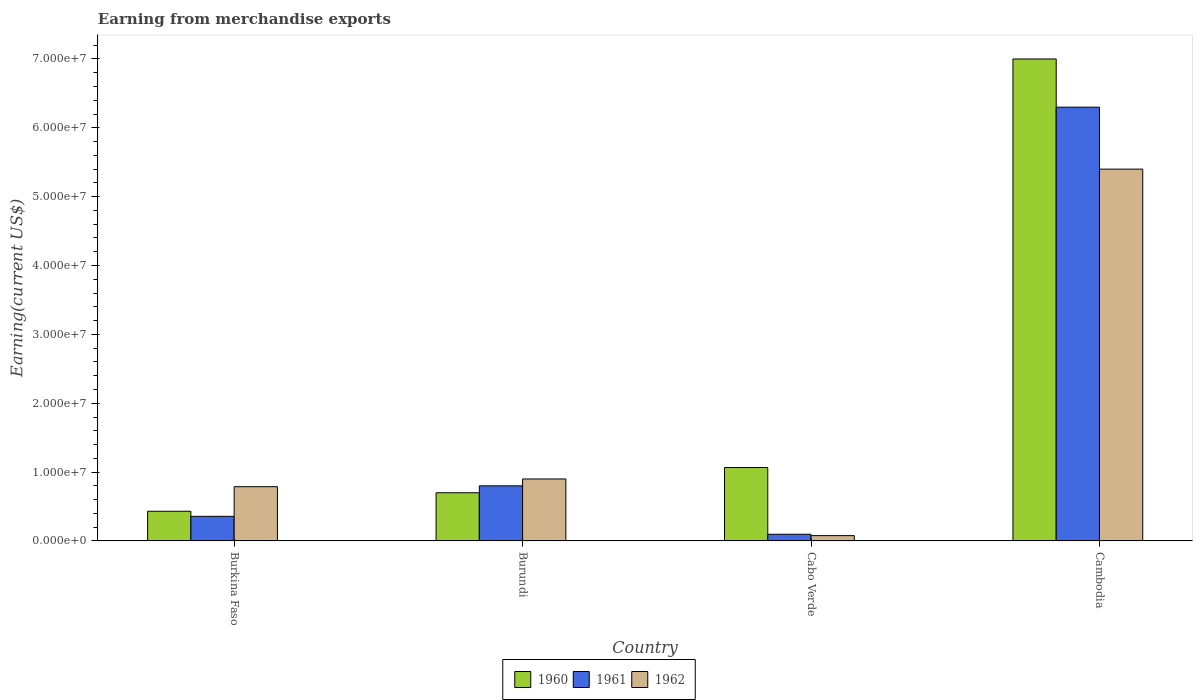How many different coloured bars are there?
Give a very brief answer. 3. Are the number of bars on each tick of the X-axis equal?
Give a very brief answer. Yes. How many bars are there on the 4th tick from the right?
Make the answer very short. 3. What is the label of the 4th group of bars from the left?
Make the answer very short. Cambodia. What is the amount earned from merchandise exports in 1961 in Cabo Verde?
Provide a short and direct response. 9.67e+05. Across all countries, what is the maximum amount earned from merchandise exports in 1960?
Your answer should be compact. 7.00e+07. Across all countries, what is the minimum amount earned from merchandise exports in 1962?
Your response must be concise. 7.72e+05. In which country was the amount earned from merchandise exports in 1962 maximum?
Keep it short and to the point. Cambodia. In which country was the amount earned from merchandise exports in 1962 minimum?
Provide a succinct answer. Cabo Verde. What is the total amount earned from merchandise exports in 1960 in the graph?
Offer a very short reply. 9.20e+07. What is the difference between the amount earned from merchandise exports in 1961 in Burkina Faso and that in Cabo Verde?
Ensure brevity in your answer.  2.61e+06. What is the difference between the amount earned from merchandise exports in 1961 in Burundi and the amount earned from merchandise exports in 1962 in Cambodia?
Your response must be concise. -4.60e+07. What is the average amount earned from merchandise exports in 1961 per country?
Make the answer very short. 1.89e+07. What is the difference between the amount earned from merchandise exports of/in 1961 and amount earned from merchandise exports of/in 1962 in Cabo Verde?
Ensure brevity in your answer.  1.95e+05. In how many countries, is the amount earned from merchandise exports in 1960 greater than 18000000 US$?
Keep it short and to the point. 1. What is the ratio of the amount earned from merchandise exports in 1961 in Burundi to that in Cabo Verde?
Provide a short and direct response. 8.27. Is the difference between the amount earned from merchandise exports in 1961 in Burkina Faso and Burundi greater than the difference between the amount earned from merchandise exports in 1962 in Burkina Faso and Burundi?
Offer a terse response. No. What is the difference between the highest and the second highest amount earned from merchandise exports in 1961?
Make the answer very short. 5.50e+07. What is the difference between the highest and the lowest amount earned from merchandise exports in 1961?
Your answer should be compact. 6.20e+07. What does the 2nd bar from the right in Cabo Verde represents?
Your response must be concise. 1961. How many bars are there?
Your response must be concise. 12. How many countries are there in the graph?
Give a very brief answer. 4. How are the legend labels stacked?
Give a very brief answer. Horizontal. What is the title of the graph?
Provide a succinct answer. Earning from merchandise exports. What is the label or title of the X-axis?
Your response must be concise. Country. What is the label or title of the Y-axis?
Offer a terse response. Earning(current US$). What is the Earning(current US$) of 1960 in Burkina Faso?
Offer a terse response. 4.31e+06. What is the Earning(current US$) in 1961 in Burkina Faso?
Provide a succinct answer. 3.57e+06. What is the Earning(current US$) in 1962 in Burkina Faso?
Provide a succinct answer. 7.88e+06. What is the Earning(current US$) of 1961 in Burundi?
Give a very brief answer. 8.00e+06. What is the Earning(current US$) of 1962 in Burundi?
Your answer should be very brief. 9.00e+06. What is the Earning(current US$) of 1960 in Cabo Verde?
Make the answer very short. 1.07e+07. What is the Earning(current US$) in 1961 in Cabo Verde?
Keep it short and to the point. 9.67e+05. What is the Earning(current US$) in 1962 in Cabo Verde?
Provide a succinct answer. 7.72e+05. What is the Earning(current US$) in 1960 in Cambodia?
Make the answer very short. 7.00e+07. What is the Earning(current US$) of 1961 in Cambodia?
Give a very brief answer. 6.30e+07. What is the Earning(current US$) of 1962 in Cambodia?
Keep it short and to the point. 5.40e+07. Across all countries, what is the maximum Earning(current US$) in 1960?
Make the answer very short. 7.00e+07. Across all countries, what is the maximum Earning(current US$) in 1961?
Your response must be concise. 6.30e+07. Across all countries, what is the maximum Earning(current US$) in 1962?
Provide a short and direct response. 5.40e+07. Across all countries, what is the minimum Earning(current US$) in 1960?
Your response must be concise. 4.31e+06. Across all countries, what is the minimum Earning(current US$) in 1961?
Offer a very short reply. 9.67e+05. Across all countries, what is the minimum Earning(current US$) of 1962?
Your answer should be compact. 7.72e+05. What is the total Earning(current US$) in 1960 in the graph?
Keep it short and to the point. 9.20e+07. What is the total Earning(current US$) of 1961 in the graph?
Offer a terse response. 7.55e+07. What is the total Earning(current US$) of 1962 in the graph?
Your response must be concise. 7.17e+07. What is the difference between the Earning(current US$) in 1960 in Burkina Faso and that in Burundi?
Offer a terse response. -2.69e+06. What is the difference between the Earning(current US$) in 1961 in Burkina Faso and that in Burundi?
Offer a very short reply. -4.43e+06. What is the difference between the Earning(current US$) of 1962 in Burkina Faso and that in Burundi?
Keep it short and to the point. -1.12e+06. What is the difference between the Earning(current US$) in 1960 in Burkina Faso and that in Cabo Verde?
Make the answer very short. -6.35e+06. What is the difference between the Earning(current US$) of 1961 in Burkina Faso and that in Cabo Verde?
Your response must be concise. 2.61e+06. What is the difference between the Earning(current US$) in 1962 in Burkina Faso and that in Cabo Verde?
Ensure brevity in your answer.  7.11e+06. What is the difference between the Earning(current US$) in 1960 in Burkina Faso and that in Cambodia?
Ensure brevity in your answer.  -6.57e+07. What is the difference between the Earning(current US$) in 1961 in Burkina Faso and that in Cambodia?
Offer a very short reply. -5.94e+07. What is the difference between the Earning(current US$) of 1962 in Burkina Faso and that in Cambodia?
Make the answer very short. -4.61e+07. What is the difference between the Earning(current US$) in 1960 in Burundi and that in Cabo Verde?
Your answer should be compact. -3.66e+06. What is the difference between the Earning(current US$) in 1961 in Burundi and that in Cabo Verde?
Provide a short and direct response. 7.03e+06. What is the difference between the Earning(current US$) in 1962 in Burundi and that in Cabo Verde?
Offer a terse response. 8.23e+06. What is the difference between the Earning(current US$) in 1960 in Burundi and that in Cambodia?
Make the answer very short. -6.30e+07. What is the difference between the Earning(current US$) of 1961 in Burundi and that in Cambodia?
Offer a terse response. -5.50e+07. What is the difference between the Earning(current US$) of 1962 in Burundi and that in Cambodia?
Provide a short and direct response. -4.50e+07. What is the difference between the Earning(current US$) in 1960 in Cabo Verde and that in Cambodia?
Your response must be concise. -5.93e+07. What is the difference between the Earning(current US$) in 1961 in Cabo Verde and that in Cambodia?
Ensure brevity in your answer.  -6.20e+07. What is the difference between the Earning(current US$) of 1962 in Cabo Verde and that in Cambodia?
Ensure brevity in your answer.  -5.32e+07. What is the difference between the Earning(current US$) in 1960 in Burkina Faso and the Earning(current US$) in 1961 in Burundi?
Offer a very short reply. -3.69e+06. What is the difference between the Earning(current US$) in 1960 in Burkina Faso and the Earning(current US$) in 1962 in Burundi?
Your answer should be very brief. -4.69e+06. What is the difference between the Earning(current US$) in 1961 in Burkina Faso and the Earning(current US$) in 1962 in Burundi?
Give a very brief answer. -5.43e+06. What is the difference between the Earning(current US$) in 1960 in Burkina Faso and the Earning(current US$) in 1961 in Cabo Verde?
Provide a short and direct response. 3.34e+06. What is the difference between the Earning(current US$) of 1960 in Burkina Faso and the Earning(current US$) of 1962 in Cabo Verde?
Offer a terse response. 3.54e+06. What is the difference between the Earning(current US$) in 1961 in Burkina Faso and the Earning(current US$) in 1962 in Cabo Verde?
Your response must be concise. 2.80e+06. What is the difference between the Earning(current US$) in 1960 in Burkina Faso and the Earning(current US$) in 1961 in Cambodia?
Your response must be concise. -5.87e+07. What is the difference between the Earning(current US$) in 1960 in Burkina Faso and the Earning(current US$) in 1962 in Cambodia?
Provide a short and direct response. -4.97e+07. What is the difference between the Earning(current US$) of 1961 in Burkina Faso and the Earning(current US$) of 1962 in Cambodia?
Keep it short and to the point. -5.04e+07. What is the difference between the Earning(current US$) of 1960 in Burundi and the Earning(current US$) of 1961 in Cabo Verde?
Your answer should be very brief. 6.03e+06. What is the difference between the Earning(current US$) in 1960 in Burundi and the Earning(current US$) in 1962 in Cabo Verde?
Provide a succinct answer. 6.23e+06. What is the difference between the Earning(current US$) of 1961 in Burundi and the Earning(current US$) of 1962 in Cabo Verde?
Ensure brevity in your answer.  7.23e+06. What is the difference between the Earning(current US$) in 1960 in Burundi and the Earning(current US$) in 1961 in Cambodia?
Offer a terse response. -5.60e+07. What is the difference between the Earning(current US$) in 1960 in Burundi and the Earning(current US$) in 1962 in Cambodia?
Keep it short and to the point. -4.70e+07. What is the difference between the Earning(current US$) of 1961 in Burundi and the Earning(current US$) of 1962 in Cambodia?
Ensure brevity in your answer.  -4.60e+07. What is the difference between the Earning(current US$) in 1960 in Cabo Verde and the Earning(current US$) in 1961 in Cambodia?
Keep it short and to the point. -5.23e+07. What is the difference between the Earning(current US$) of 1960 in Cabo Verde and the Earning(current US$) of 1962 in Cambodia?
Provide a short and direct response. -4.33e+07. What is the difference between the Earning(current US$) of 1961 in Cabo Verde and the Earning(current US$) of 1962 in Cambodia?
Your response must be concise. -5.30e+07. What is the average Earning(current US$) of 1960 per country?
Offer a very short reply. 2.30e+07. What is the average Earning(current US$) of 1961 per country?
Give a very brief answer. 1.89e+07. What is the average Earning(current US$) in 1962 per country?
Provide a short and direct response. 1.79e+07. What is the difference between the Earning(current US$) of 1960 and Earning(current US$) of 1961 in Burkina Faso?
Make the answer very short. 7.37e+05. What is the difference between the Earning(current US$) in 1960 and Earning(current US$) in 1962 in Burkina Faso?
Your response must be concise. -3.57e+06. What is the difference between the Earning(current US$) of 1961 and Earning(current US$) of 1962 in Burkina Faso?
Give a very brief answer. -4.31e+06. What is the difference between the Earning(current US$) of 1960 and Earning(current US$) of 1962 in Burundi?
Provide a short and direct response. -2.00e+06. What is the difference between the Earning(current US$) of 1961 and Earning(current US$) of 1962 in Burundi?
Your response must be concise. -1.00e+06. What is the difference between the Earning(current US$) in 1960 and Earning(current US$) in 1961 in Cabo Verde?
Give a very brief answer. 9.69e+06. What is the difference between the Earning(current US$) of 1960 and Earning(current US$) of 1962 in Cabo Verde?
Your response must be concise. 9.89e+06. What is the difference between the Earning(current US$) in 1961 and Earning(current US$) in 1962 in Cabo Verde?
Your answer should be very brief. 1.95e+05. What is the difference between the Earning(current US$) of 1960 and Earning(current US$) of 1961 in Cambodia?
Offer a very short reply. 7.00e+06. What is the difference between the Earning(current US$) in 1960 and Earning(current US$) in 1962 in Cambodia?
Ensure brevity in your answer.  1.60e+07. What is the difference between the Earning(current US$) of 1961 and Earning(current US$) of 1962 in Cambodia?
Offer a terse response. 9.00e+06. What is the ratio of the Earning(current US$) of 1960 in Burkina Faso to that in Burundi?
Ensure brevity in your answer.  0.62. What is the ratio of the Earning(current US$) in 1961 in Burkina Faso to that in Burundi?
Provide a short and direct response. 0.45. What is the ratio of the Earning(current US$) in 1962 in Burkina Faso to that in Burundi?
Your answer should be very brief. 0.88. What is the ratio of the Earning(current US$) of 1960 in Burkina Faso to that in Cabo Verde?
Keep it short and to the point. 0.4. What is the ratio of the Earning(current US$) of 1961 in Burkina Faso to that in Cabo Verde?
Give a very brief answer. 3.69. What is the ratio of the Earning(current US$) of 1962 in Burkina Faso to that in Cabo Verde?
Offer a terse response. 10.21. What is the ratio of the Earning(current US$) in 1960 in Burkina Faso to that in Cambodia?
Provide a short and direct response. 0.06. What is the ratio of the Earning(current US$) in 1961 in Burkina Faso to that in Cambodia?
Make the answer very short. 0.06. What is the ratio of the Earning(current US$) of 1962 in Burkina Faso to that in Cambodia?
Give a very brief answer. 0.15. What is the ratio of the Earning(current US$) in 1960 in Burundi to that in Cabo Verde?
Ensure brevity in your answer.  0.66. What is the ratio of the Earning(current US$) in 1961 in Burundi to that in Cabo Verde?
Your answer should be compact. 8.27. What is the ratio of the Earning(current US$) of 1962 in Burundi to that in Cabo Verde?
Ensure brevity in your answer.  11.66. What is the ratio of the Earning(current US$) in 1961 in Burundi to that in Cambodia?
Make the answer very short. 0.13. What is the ratio of the Earning(current US$) in 1962 in Burundi to that in Cambodia?
Provide a short and direct response. 0.17. What is the ratio of the Earning(current US$) in 1960 in Cabo Verde to that in Cambodia?
Your response must be concise. 0.15. What is the ratio of the Earning(current US$) in 1961 in Cabo Verde to that in Cambodia?
Make the answer very short. 0.02. What is the ratio of the Earning(current US$) of 1962 in Cabo Verde to that in Cambodia?
Your answer should be compact. 0.01. What is the difference between the highest and the second highest Earning(current US$) of 1960?
Your answer should be very brief. 5.93e+07. What is the difference between the highest and the second highest Earning(current US$) in 1961?
Offer a very short reply. 5.50e+07. What is the difference between the highest and the second highest Earning(current US$) of 1962?
Provide a succinct answer. 4.50e+07. What is the difference between the highest and the lowest Earning(current US$) in 1960?
Offer a very short reply. 6.57e+07. What is the difference between the highest and the lowest Earning(current US$) of 1961?
Provide a short and direct response. 6.20e+07. What is the difference between the highest and the lowest Earning(current US$) of 1962?
Offer a very short reply. 5.32e+07. 